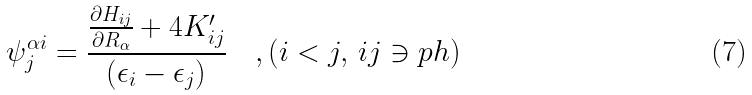Convert formula to latex. <formula><loc_0><loc_0><loc_500><loc_500>\psi _ { j } ^ { \alpha i } = \frac { \frac { \partial H _ { i j } } { \partial R _ { \alpha } } + 4 K _ { i j } ^ { \prime } } { ( \epsilon _ { i } - \epsilon _ { j } ) } \quad , ( i < j , \, i j \ni p h )</formula> 